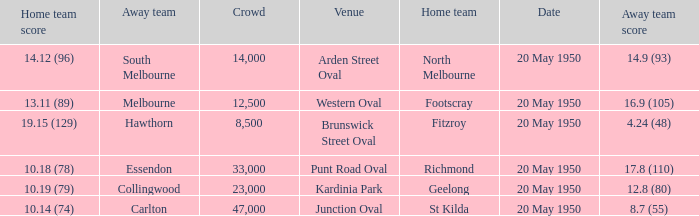What was the largest crowd to view a game where the away team scored 17.8 (110)? 33000.0. 